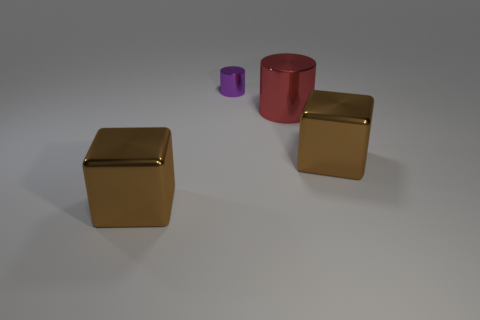Is there any other thing that has the same size as the purple cylinder?
Your answer should be compact. No. Are there the same number of tiny things to the right of the purple metallic object and yellow cylinders?
Your answer should be compact. Yes. What is the color of the small object?
Make the answer very short. Purple. The red cylinder that is made of the same material as the purple cylinder is what size?
Your answer should be very brief. Large. There is another cylinder that is made of the same material as the purple cylinder; what is its color?
Give a very brief answer. Red. Are there any other purple metal things that have the same size as the purple object?
Ensure brevity in your answer.  No. There is another red object that is the same shape as the tiny shiny thing; what is its material?
Provide a short and direct response. Metal. Is there another thing that has the same shape as the red thing?
Provide a short and direct response. Yes. There is a red object behind the brown cube left of the tiny purple cylinder; what is its shape?
Make the answer very short. Cylinder. There is a big cylinder on the left side of the big cube that is behind the large brown block to the left of the tiny metal thing; what is it made of?
Your response must be concise. Metal. 